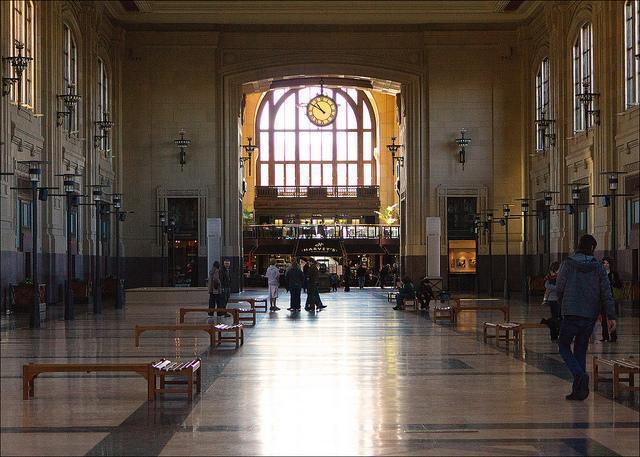What is on the left side of the room?
Select the accurate answer and provide justification: `Answer: choice
Rationale: srationale.`
Options: Barrel, wheelbarrow, bench, apple cart. Answer: bench.
Rationale: The furniture is long has no backside or armrests. 